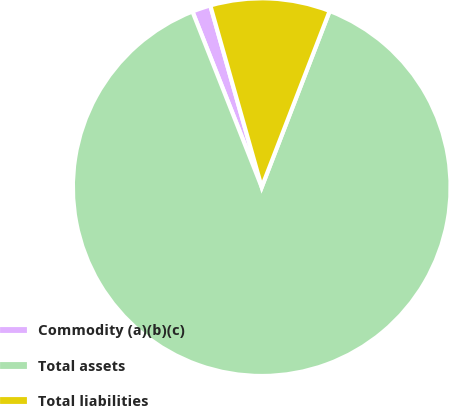Convert chart. <chart><loc_0><loc_0><loc_500><loc_500><pie_chart><fcel>Commodity (a)(b)(c)<fcel>Total assets<fcel>Total liabilities<nl><fcel>1.59%<fcel>88.16%<fcel>10.25%<nl></chart> 